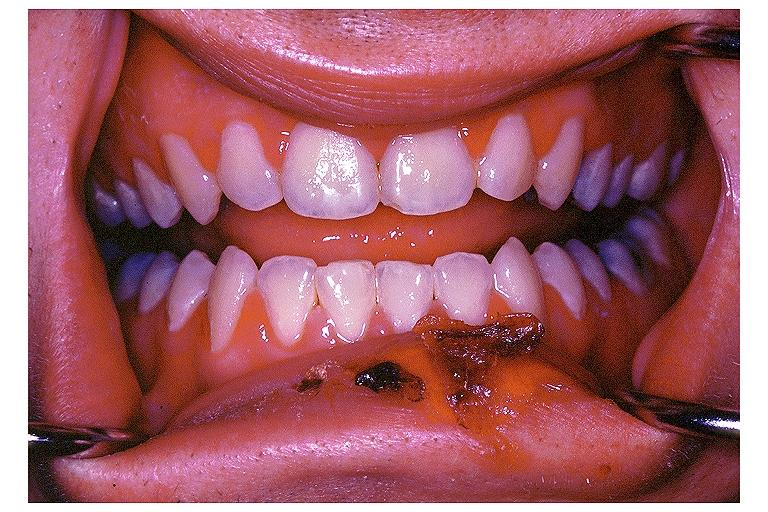s oral present?
Answer the question using a single word or phrase. Yes 